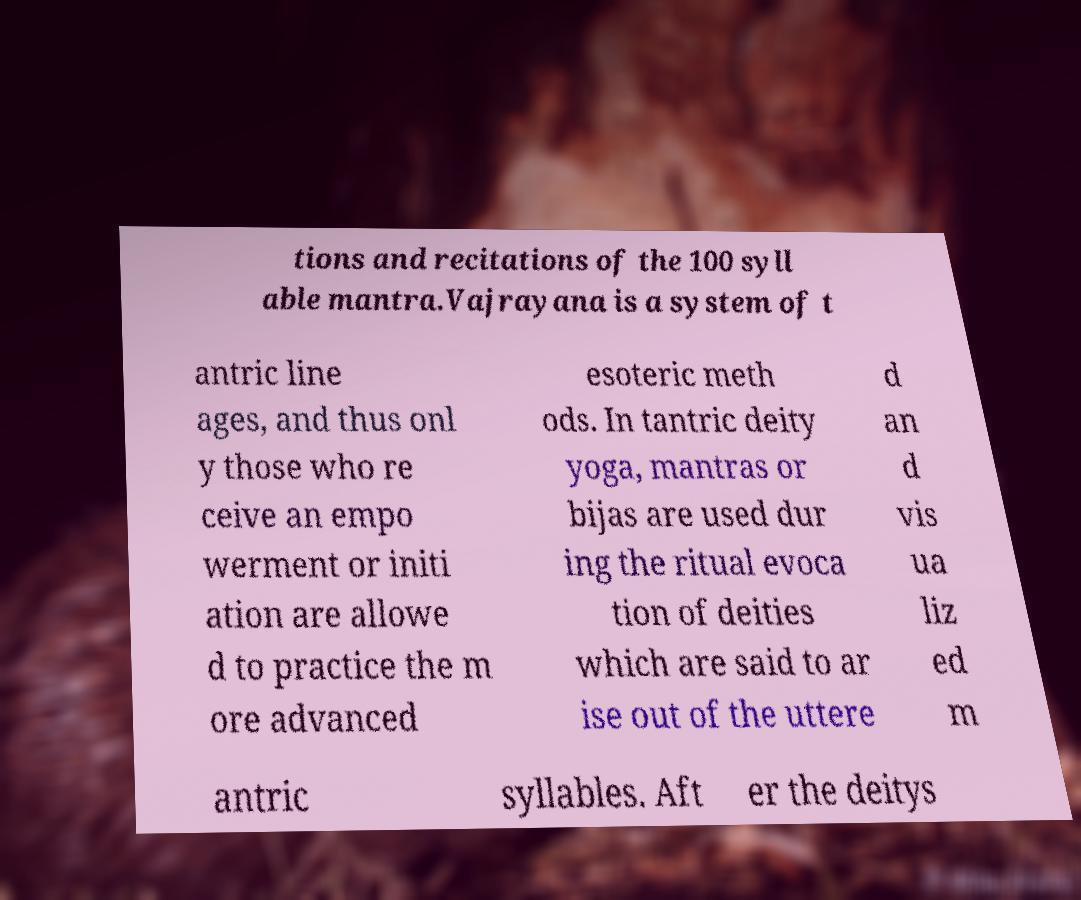Please read and relay the text visible in this image. What does it say? tions and recitations of the 100 syll able mantra.Vajrayana is a system of t antric line ages, and thus onl y those who re ceive an empo werment or initi ation are allowe d to practice the m ore advanced esoteric meth ods. In tantric deity yoga, mantras or bijas are used dur ing the ritual evoca tion of deities which are said to ar ise out of the uttere d an d vis ua liz ed m antric syllables. Aft er the deitys 